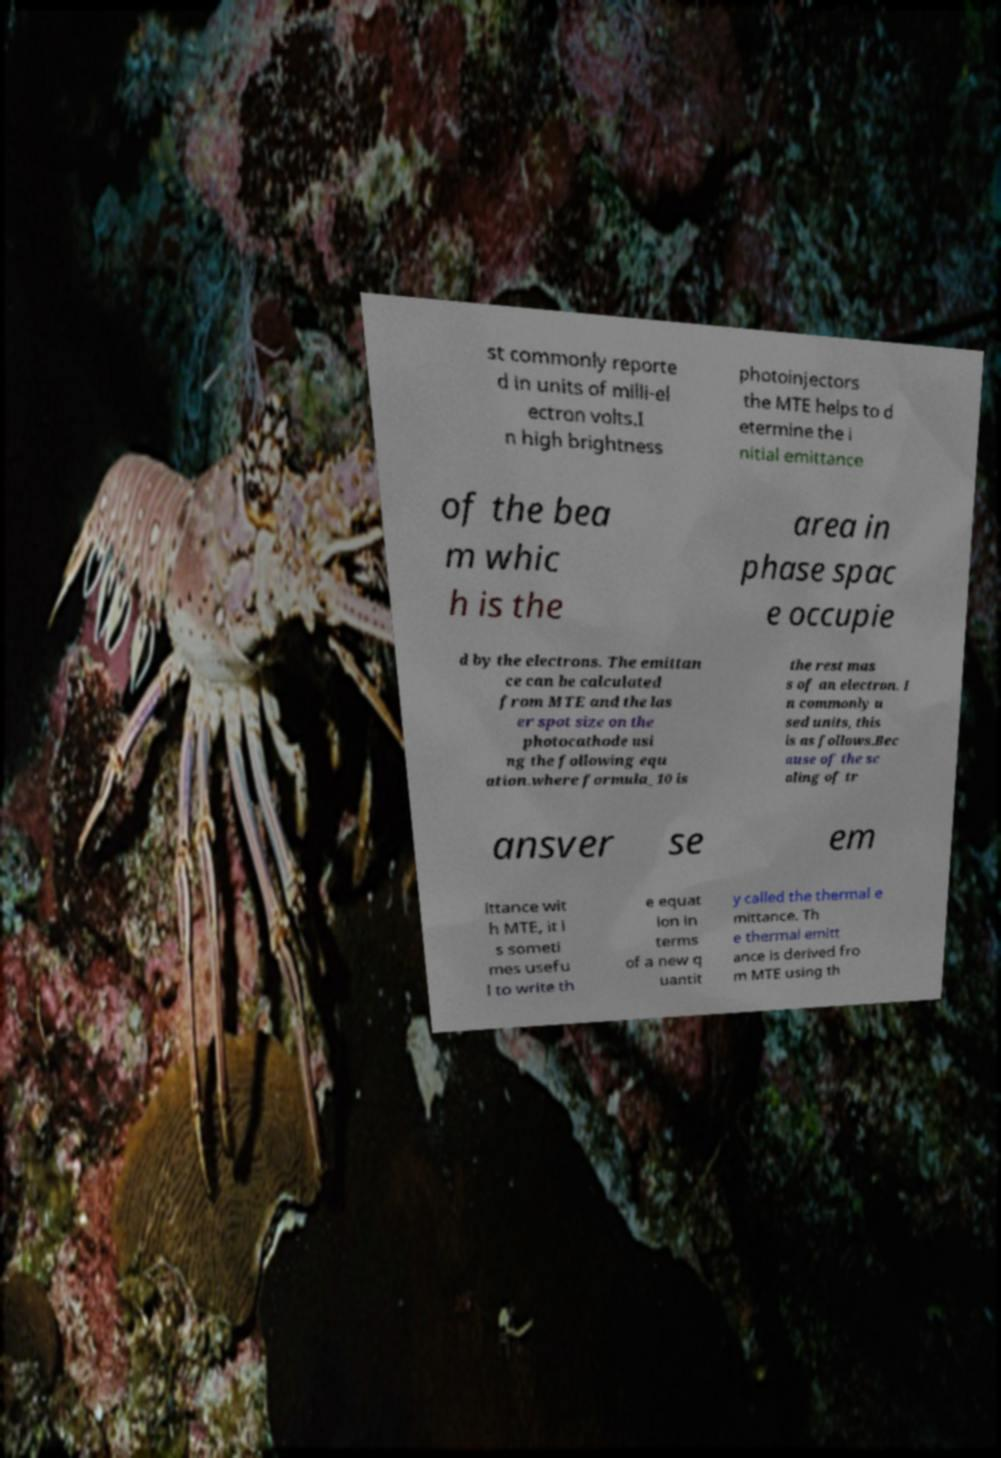Can you read and provide the text displayed in the image?This photo seems to have some interesting text. Can you extract and type it out for me? st commonly reporte d in units of milli-el ectron volts.I n high brightness photoinjectors the MTE helps to d etermine the i nitial emittance of the bea m whic h is the area in phase spac e occupie d by the electrons. The emittan ce can be calculated from MTE and the las er spot size on the photocathode usi ng the following equ ation.where formula_10 is the rest mas s of an electron. I n commonly u sed units, this is as follows.Bec ause of the sc aling of tr ansver se em ittance wit h MTE, it i s someti mes usefu l to write th e equat ion in terms of a new q uantit y called the thermal e mittance. Th e thermal emitt ance is derived fro m MTE using th 